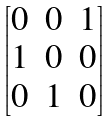<formula> <loc_0><loc_0><loc_500><loc_500>\begin{bmatrix} 0 & 0 & 1 \\ 1 & 0 & 0 \\ 0 & 1 & 0 \end{bmatrix}</formula> 